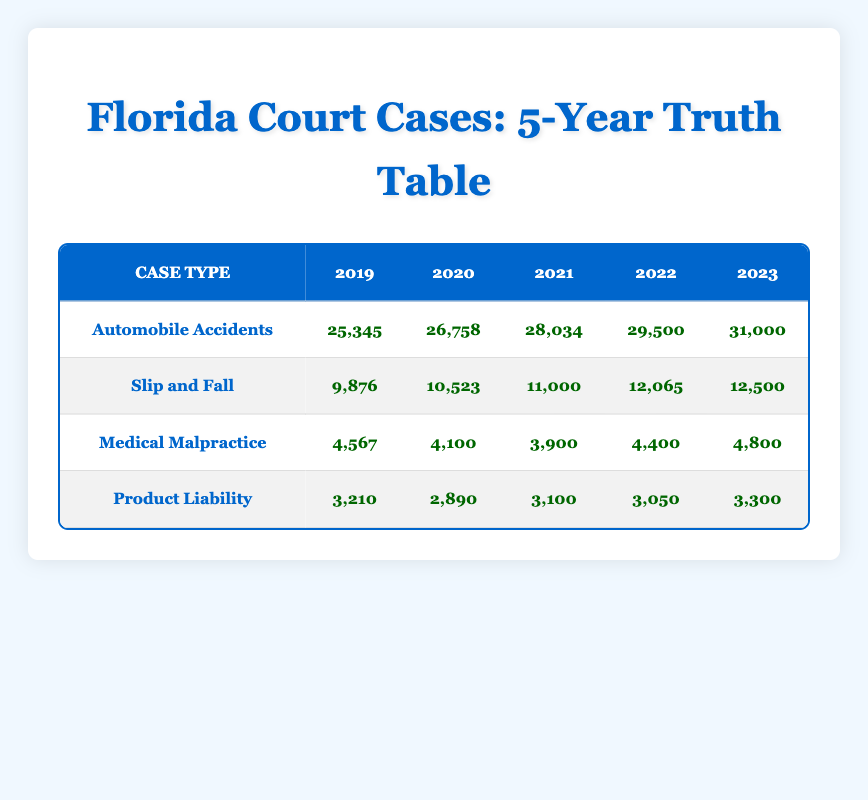What was the case count for Automobile Accidents in 2020? The table shows that in 2020, the case count for Automobile Accidents is listed directly under that case type in the corresponding column for the year. The value is 26,758.
Answer: 26,758 Which case type had the highest count in 2022? By examining the 2022 row, we can see the values for each case type: Automobile Accidents: 29,500, Slip and Fall: 12,065, Medical Malpractice: 4,400, and Product Liability: 3,050. Among these, Automobile Accidents has the highest count.
Answer: Automobile Accidents Did the case count for Medical Malpractice increase or decrease from 2021 to 2022? Checking the counts for Medical Malpractice in both years, in 2021 it had 3,900 cases, and in 2022 it increased to 4,400 cases. Thus, the case count increased.
Answer: Yes What is the total number of Slip and Fall cases filed over the five years? We will sum the counts from each year: 9,876 (2019) + 10,523 (2020) + 11,000 (2021) + 12,065 (2022) + 12,500 (2023) = 56,964. Therefore, the total number of cases is 56,964.
Answer: 56,964 How many more cases of Automobile Accidents were there in 2023 than in 2019? We compare the case counts: For 2023, there were 31,000 cases and for 2019, there were 25,345 cases. The difference is 31,000 - 25,345 = 5,655, indicating there were 5,655 more cases in 2023.
Answer: 5,655 Was there a year when the case count for Product Liability was higher than 3,200? Upon checking the counts: In 2019 it was 3,210, in 2020 it was 2,890 (no), in 2021 it was 3,100 (no), in 2022 it was 3,050 (no), and in 2023 it was 3,300 (yes). Thus, there were years where it was above 3,200.
Answer: Yes What was the average case count for Slip and Fall cases across all five years? We sum the counts: 9,876 + 10,523 + 11,000 + 12,065 + 12,500 = 56,964 and then divide by 5 (the number of years): 56,964 / 5 = 11,392.8. Therefore, the average count is 11,392.8.
Answer: 11,392.8 Which case type saw the largest increase in case count from 2019 to 2023? We will find the difference for each case type between these years: Automobile Accidents increase: 31,000 - 25,345 = 5,655, Slip and Fall increase: 12,500 - 9,876 = 2,624, Medical Malpractice increase: 4,800 - 4,567 = 233, Product Liability increase: 3,300 - 3,210 = 90. The largest increase is for Automobile Accidents at 5,655.
Answer: Automobile Accidents In which year was the count for Medical Malpractice the lowest? Reviewing the counts for Medical Malpractice: 4,567 (2019), 4,100 (2020), 3,900 (2021), 4,400 (2022), and 4,800 (2023), the lowest count is seen in 2021 at 3,900.
Answer: 2021 